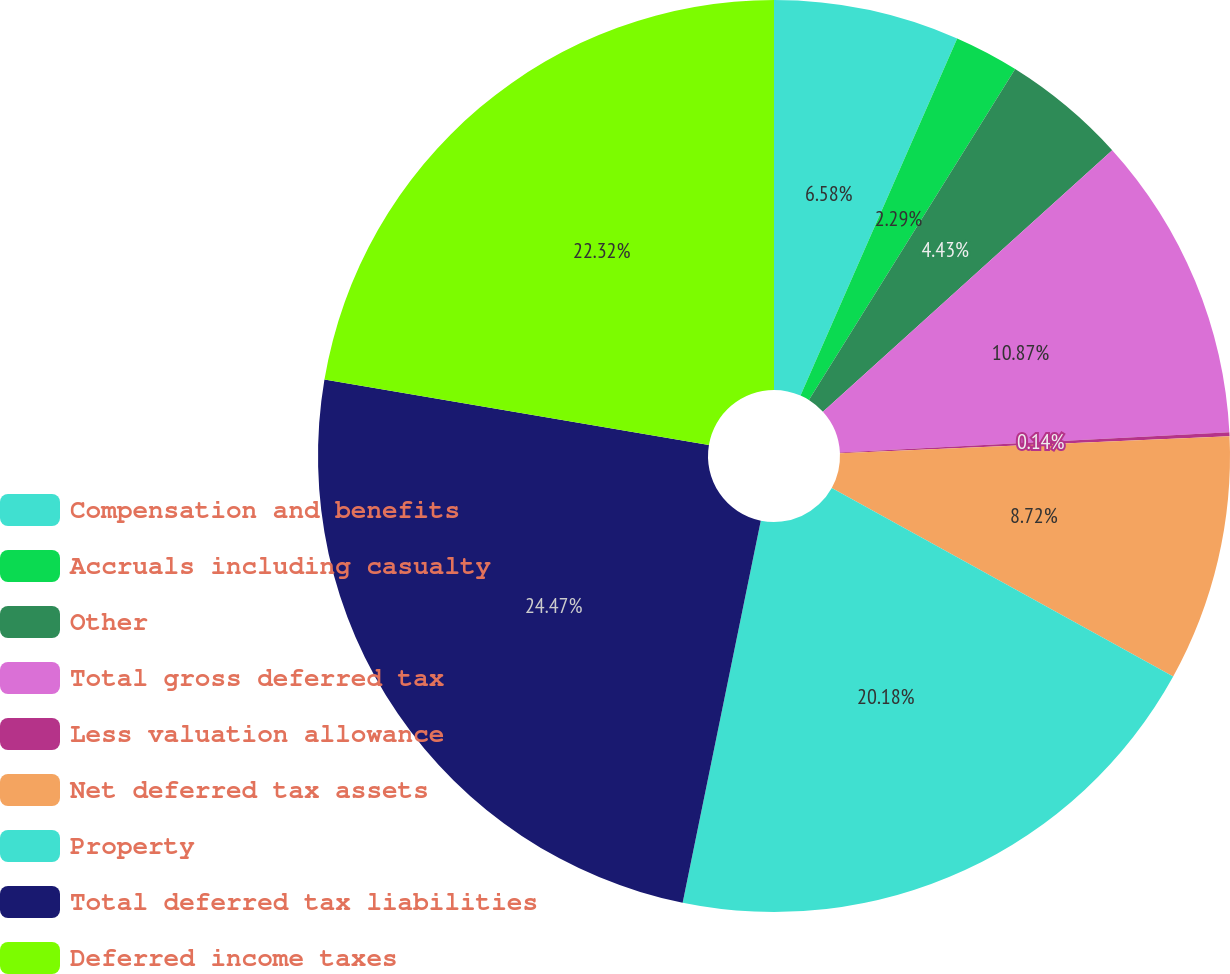Convert chart to OTSL. <chart><loc_0><loc_0><loc_500><loc_500><pie_chart><fcel>Compensation and benefits<fcel>Accruals including casualty<fcel>Other<fcel>Total gross deferred tax<fcel>Less valuation allowance<fcel>Net deferred tax assets<fcel>Property<fcel>Total deferred tax liabilities<fcel>Deferred income taxes<nl><fcel>6.58%<fcel>2.29%<fcel>4.43%<fcel>10.87%<fcel>0.14%<fcel>8.72%<fcel>20.18%<fcel>24.47%<fcel>22.32%<nl></chart> 